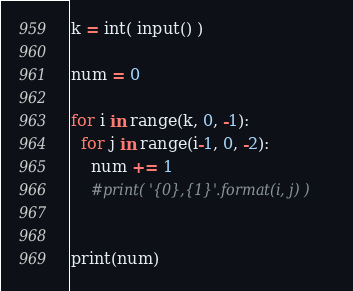Convert code to text. <code><loc_0><loc_0><loc_500><loc_500><_Python_>k = int( input() )

num = 0

for i in range(k, 0, -1):
  for j in range(i-1, 0, -2):
    num += 1
    #print( '{0},{1}'.format(i, j) )
    
    
print(num)</code> 